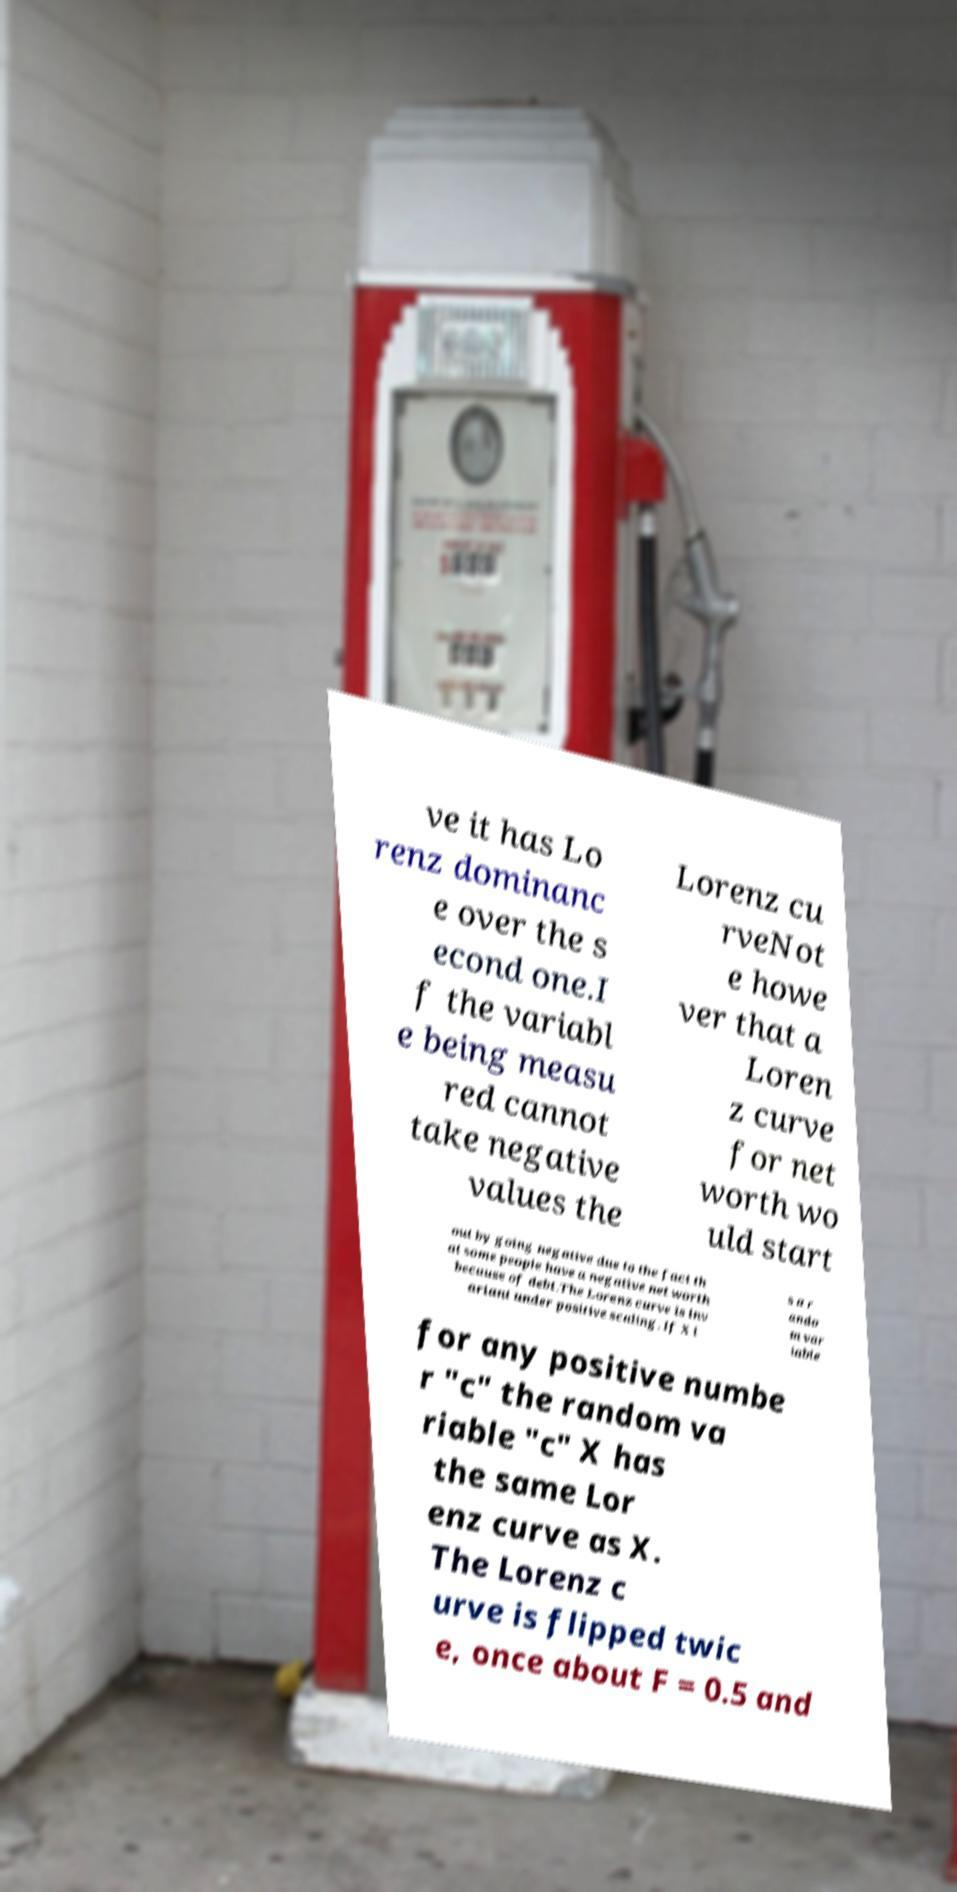For documentation purposes, I need the text within this image transcribed. Could you provide that? ve it has Lo renz dominanc e over the s econd one.I f the variabl e being measu red cannot take negative values the Lorenz cu rveNot e howe ver that a Loren z curve for net worth wo uld start out by going negative due to the fact th at some people have a negative net worth because of debt.The Lorenz curve is inv ariant under positive scaling. If X i s a r ando m var iable for any positive numbe r "c" the random va riable "c" X has the same Lor enz curve as X. The Lorenz c urve is flipped twic e, once about F = 0.5 and 